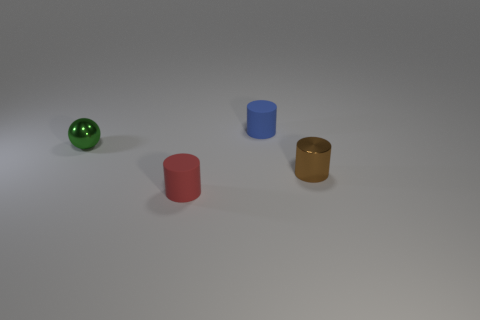What materials are the objects in the image possibly made of? The image showcases several objects which appear to be made from different materials. The green sphere has a glossy finish, suggesting it could be ceramic or perhaps enameled metal. The cylinders have a duller appearance; the red seems to be matte and could be rubber or plastic, whereas the blue and golden ones have a slight sheen, indicating they might be made of metal. 